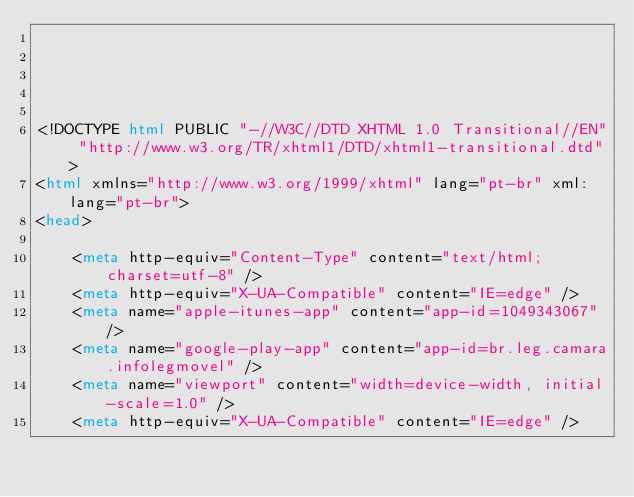Convert code to text. <code><loc_0><loc_0><loc_500><loc_500><_HTML_>




<!DOCTYPE html PUBLIC "-//W3C//DTD XHTML 1.0 Transitional//EN" "http://www.w3.org/TR/xhtml1/DTD/xhtml1-transitional.dtd">
<html xmlns="http://www.w3.org/1999/xhtml" lang="pt-br" xml:lang="pt-br">
<head>
	    
    <meta http-equiv="Content-Type" content="text/html; charset=utf-8" />
    <meta http-equiv="X-UA-Compatible" content="IE=edge" />
    <meta name="apple-itunes-app" content="app-id=1049343067" />
    <meta name="google-play-app" content="app-id=br.leg.camara.infolegmovel" />
    <meta name="viewport" content="width=device-width, initial-scale=1.0" />
	<meta http-equiv="X-UA-Compatible" content="IE=edge" /> 
    </code> 